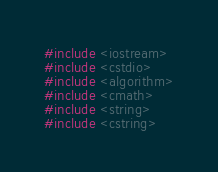Convert code to text. <code><loc_0><loc_0><loc_500><loc_500><_C++_>#include <iostream>
#include <cstdio>
#include <algorithm>
#include <cmath>
#include <string>
#include <cstring></code> 